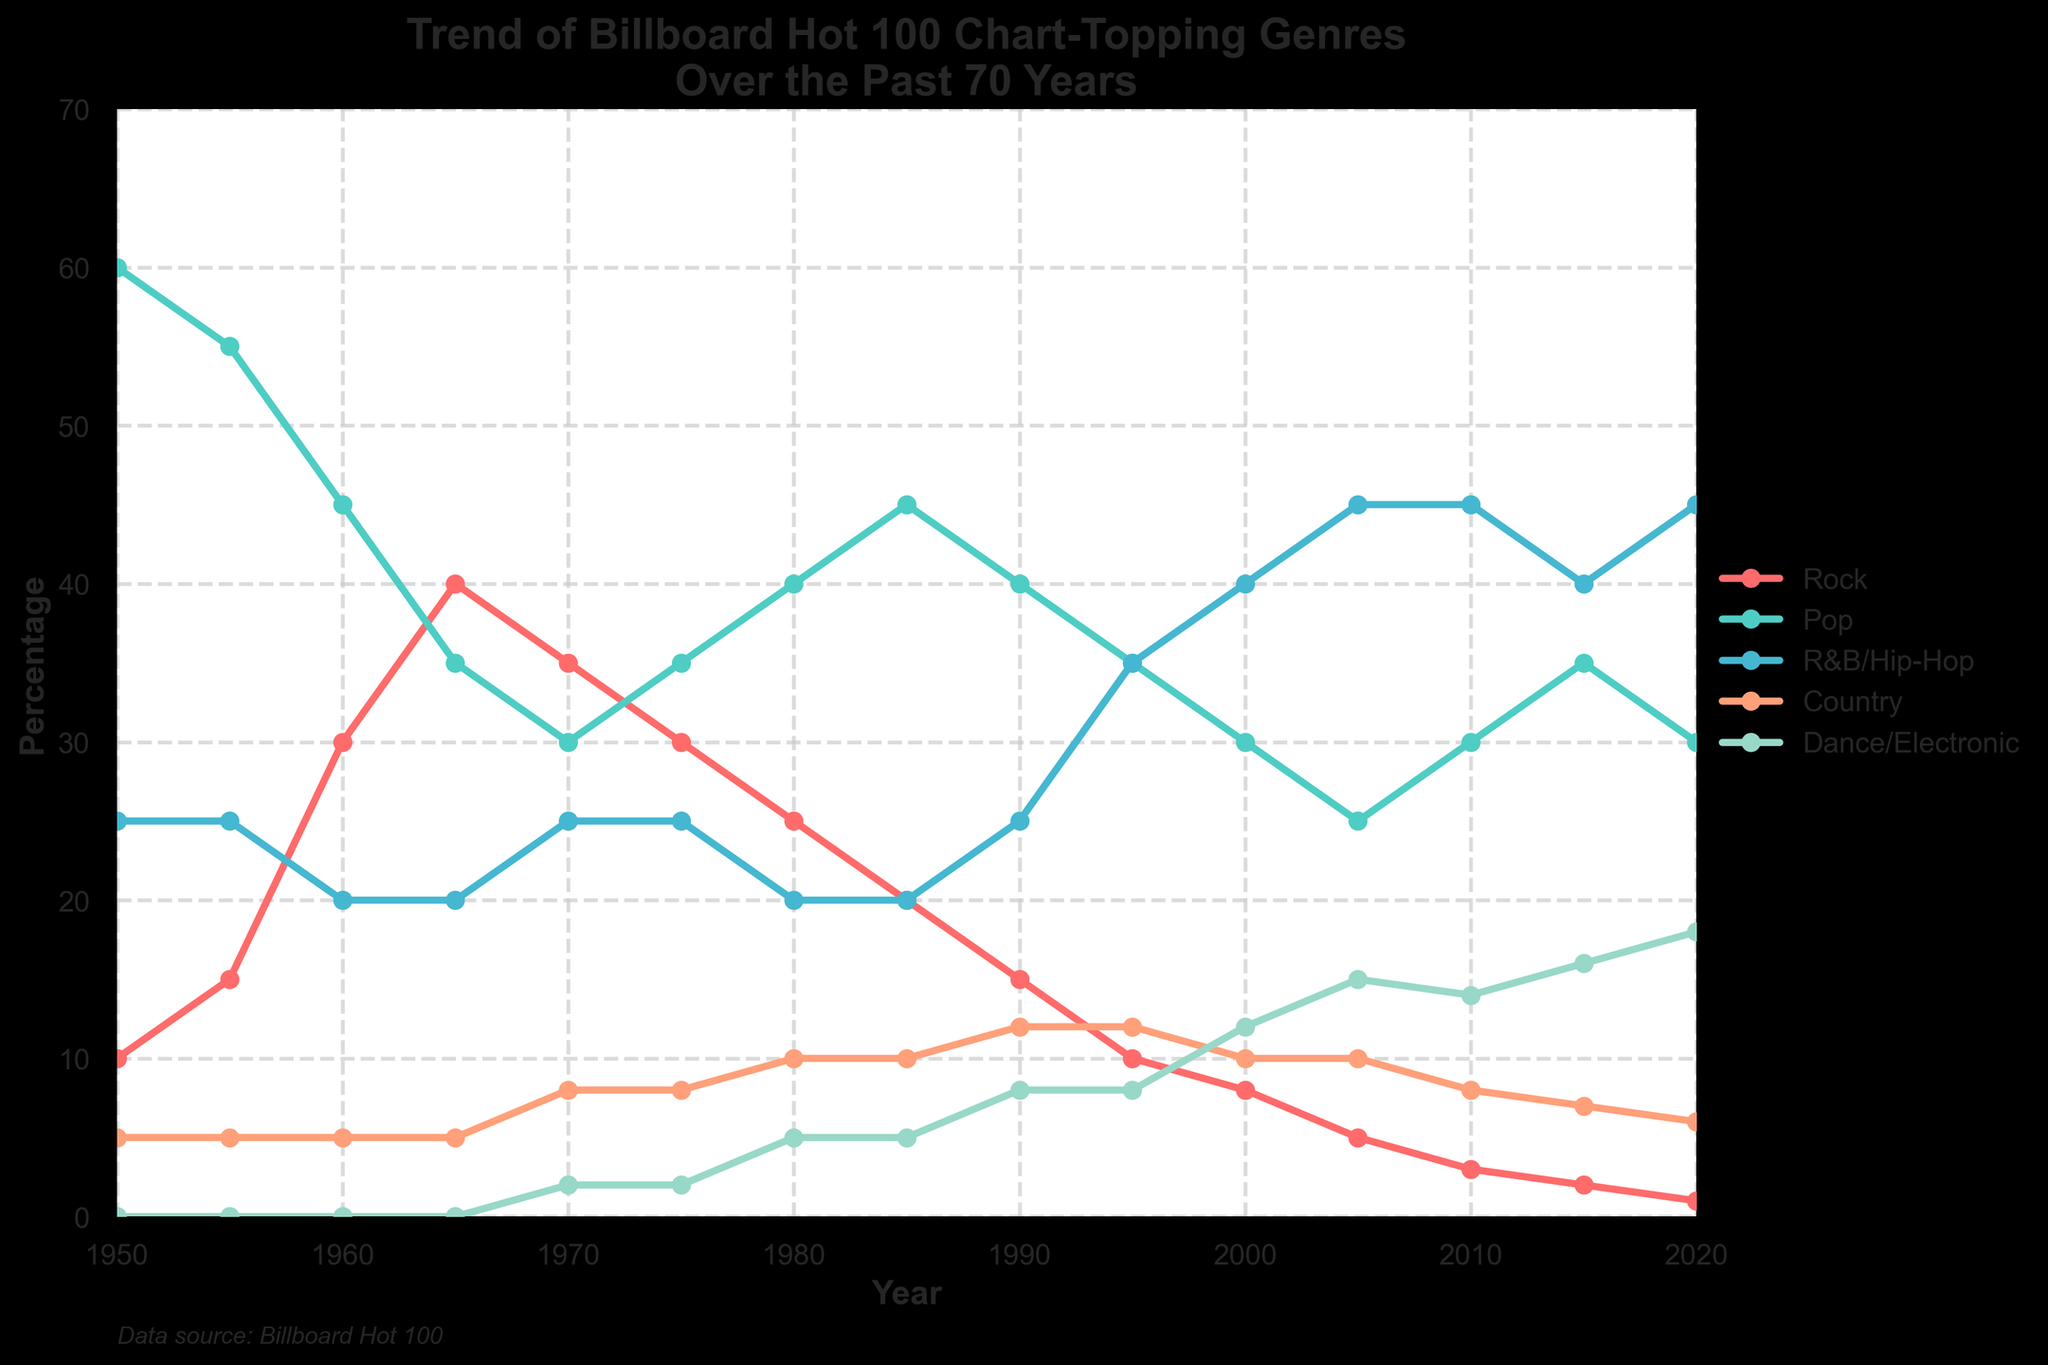What genre showed the highest percentage in 1950? Looking at the line chart, we see that Pop had the highest percentage around 60% in 1950.
Answer: Pop Which genre has shown a consistent increase over the years from 1950 to 2020? The Dance/Electronic genre starts at 0% in 1950 and increases steadily to 18% in 2020, showing a consistent upward trend.
Answer: Dance/Electronic How did the percentage of Rock change between 1965 and 2020? In 1965, Rock was at 40%. By 2020, it had decreased to 1%. The change is a decrease of 39%.
Answer: Decreased by 39% In which decade did R&B/Hip-Hop surpass Rock in popularity? R&B/Hip-Hop surpassed Rock between the 1990s and 2000s. By the year 2000, R&B/Hip-Hop was at 40%, and Rock had decreased to 8%.
Answer: Between the 1990s and 2000s By what percentage did Pop's popularity decrease from 1980 to 2000? In 1980, Pop was at 40%. By 2000, it had decreased to 30%. The change is a decrease of 10%.
Answer: 10% Which two genres were closest in terms of percentage in 1975? In 1975, Rock and Pop were closest in percentage, with Rock at 30% and Pop at 35%, differing by 5%.
Answer: Rock and Pop What was the combined percentage of R&B/Hip-Hop and Dance/Electronic in 2020? In 2020, R&B/Hip-Hop was at 45%, and Dance/Electronic was at 18%. The combined percentage is 45% + 18% = 63%.
Answer: 63% During which decade did Country show the highest percentage? Country peaked at 12% in the 1990s and early 2000s.
Answer: 1990s and early 2000s Which genre has consistently been the least popular over the years? Country has consistently been one of the least popular genres, staying relatively flat and never exceeding 12%.
Answer: Country 